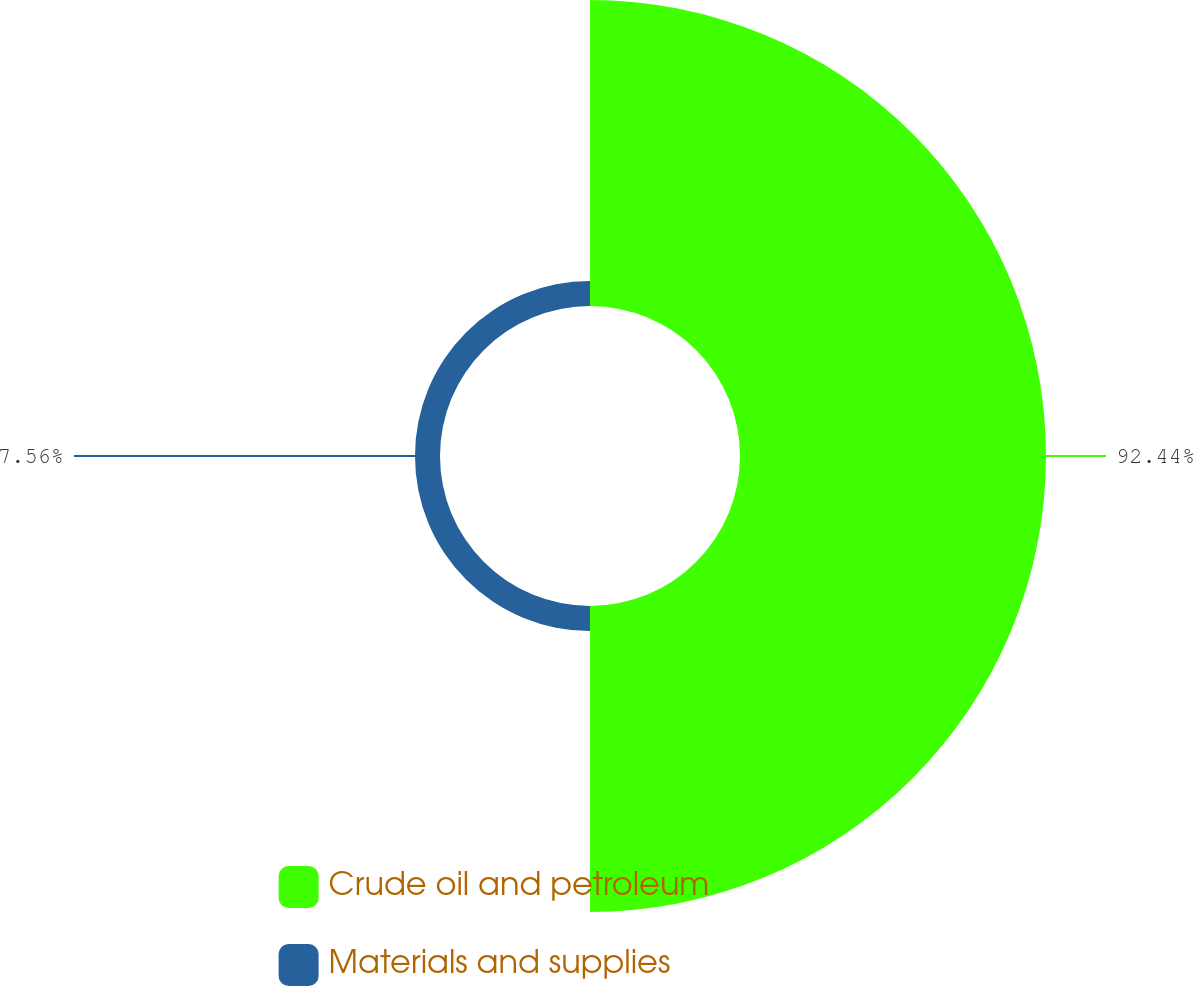Convert chart. <chart><loc_0><loc_0><loc_500><loc_500><pie_chart><fcel>Crude oil and petroleum<fcel>Materials and supplies<nl><fcel>92.44%<fcel>7.56%<nl></chart> 